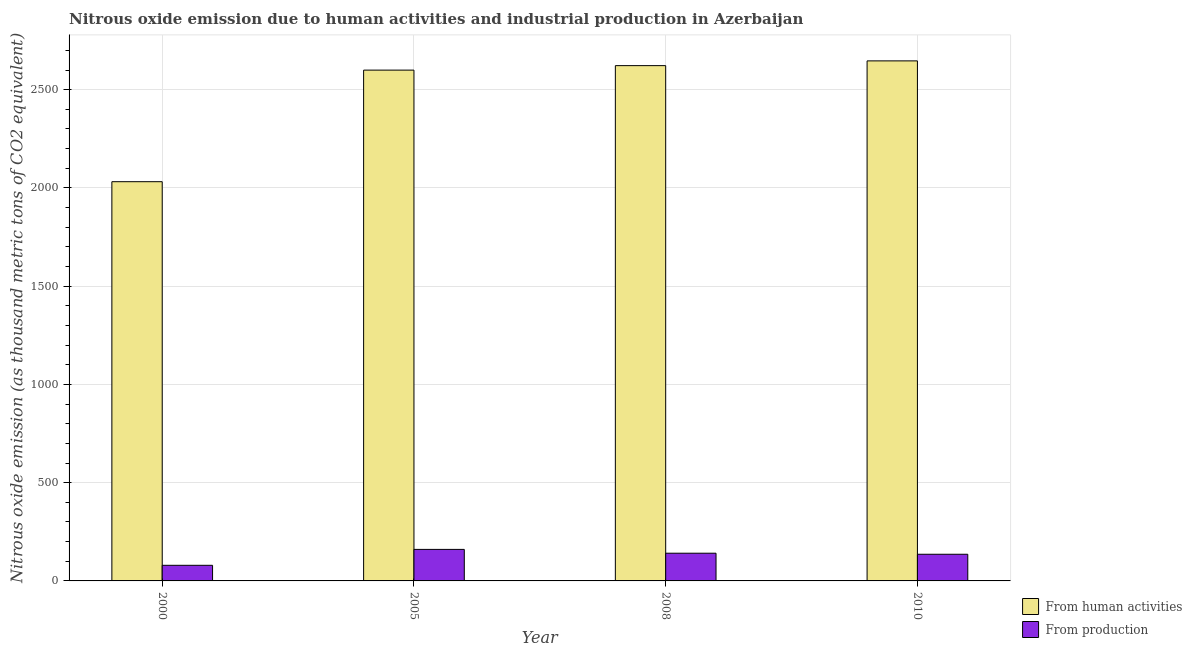How many different coloured bars are there?
Your answer should be very brief. 2. How many groups of bars are there?
Your response must be concise. 4. Are the number of bars per tick equal to the number of legend labels?
Your answer should be very brief. Yes. Are the number of bars on each tick of the X-axis equal?
Keep it short and to the point. Yes. How many bars are there on the 4th tick from the left?
Keep it short and to the point. 2. How many bars are there on the 1st tick from the right?
Offer a very short reply. 2. In how many cases, is the number of bars for a given year not equal to the number of legend labels?
Your answer should be compact. 0. What is the amount of emissions generated from industries in 2000?
Keep it short and to the point. 79.5. Across all years, what is the maximum amount of emissions generated from industries?
Provide a short and direct response. 160.4. Across all years, what is the minimum amount of emissions generated from industries?
Your response must be concise. 79.5. In which year was the amount of emissions from human activities minimum?
Offer a very short reply. 2000. What is the total amount of emissions generated from industries in the graph?
Your answer should be compact. 516.6. What is the difference between the amount of emissions from human activities in 2008 and that in 2010?
Keep it short and to the point. -24.2. What is the difference between the amount of emissions generated from industries in 2008 and the amount of emissions from human activities in 2010?
Your answer should be very brief. 5.3. What is the average amount of emissions from human activities per year?
Make the answer very short. 2475.08. What is the ratio of the amount of emissions generated from industries in 2000 to that in 2010?
Your response must be concise. 0.59. What is the difference between the highest and the second highest amount of emissions from human activities?
Offer a terse response. 24.2. What is the difference between the highest and the lowest amount of emissions from human activities?
Your response must be concise. 614.9. Is the sum of the amount of emissions from human activities in 2000 and 2010 greater than the maximum amount of emissions generated from industries across all years?
Make the answer very short. Yes. What does the 1st bar from the left in 2005 represents?
Your response must be concise. From human activities. What does the 2nd bar from the right in 2010 represents?
Provide a short and direct response. From human activities. Are the values on the major ticks of Y-axis written in scientific E-notation?
Offer a very short reply. No. Does the graph contain grids?
Give a very brief answer. Yes. What is the title of the graph?
Your response must be concise. Nitrous oxide emission due to human activities and industrial production in Azerbaijan. What is the label or title of the X-axis?
Keep it short and to the point. Year. What is the label or title of the Y-axis?
Provide a succinct answer. Nitrous oxide emission (as thousand metric tons of CO2 equivalent). What is the Nitrous oxide emission (as thousand metric tons of CO2 equivalent) in From human activities in 2000?
Your answer should be very brief. 2031.7. What is the Nitrous oxide emission (as thousand metric tons of CO2 equivalent) of From production in 2000?
Your answer should be compact. 79.5. What is the Nitrous oxide emission (as thousand metric tons of CO2 equivalent) in From human activities in 2005?
Your answer should be compact. 2599.6. What is the Nitrous oxide emission (as thousand metric tons of CO2 equivalent) of From production in 2005?
Your response must be concise. 160.4. What is the Nitrous oxide emission (as thousand metric tons of CO2 equivalent) in From human activities in 2008?
Provide a short and direct response. 2622.4. What is the Nitrous oxide emission (as thousand metric tons of CO2 equivalent) of From production in 2008?
Make the answer very short. 141. What is the Nitrous oxide emission (as thousand metric tons of CO2 equivalent) of From human activities in 2010?
Ensure brevity in your answer.  2646.6. What is the Nitrous oxide emission (as thousand metric tons of CO2 equivalent) of From production in 2010?
Give a very brief answer. 135.7. Across all years, what is the maximum Nitrous oxide emission (as thousand metric tons of CO2 equivalent) in From human activities?
Make the answer very short. 2646.6. Across all years, what is the maximum Nitrous oxide emission (as thousand metric tons of CO2 equivalent) of From production?
Offer a very short reply. 160.4. Across all years, what is the minimum Nitrous oxide emission (as thousand metric tons of CO2 equivalent) in From human activities?
Make the answer very short. 2031.7. Across all years, what is the minimum Nitrous oxide emission (as thousand metric tons of CO2 equivalent) of From production?
Your response must be concise. 79.5. What is the total Nitrous oxide emission (as thousand metric tons of CO2 equivalent) of From human activities in the graph?
Offer a very short reply. 9900.3. What is the total Nitrous oxide emission (as thousand metric tons of CO2 equivalent) in From production in the graph?
Give a very brief answer. 516.6. What is the difference between the Nitrous oxide emission (as thousand metric tons of CO2 equivalent) of From human activities in 2000 and that in 2005?
Provide a succinct answer. -567.9. What is the difference between the Nitrous oxide emission (as thousand metric tons of CO2 equivalent) in From production in 2000 and that in 2005?
Keep it short and to the point. -80.9. What is the difference between the Nitrous oxide emission (as thousand metric tons of CO2 equivalent) of From human activities in 2000 and that in 2008?
Ensure brevity in your answer.  -590.7. What is the difference between the Nitrous oxide emission (as thousand metric tons of CO2 equivalent) of From production in 2000 and that in 2008?
Your answer should be compact. -61.5. What is the difference between the Nitrous oxide emission (as thousand metric tons of CO2 equivalent) of From human activities in 2000 and that in 2010?
Ensure brevity in your answer.  -614.9. What is the difference between the Nitrous oxide emission (as thousand metric tons of CO2 equivalent) of From production in 2000 and that in 2010?
Provide a short and direct response. -56.2. What is the difference between the Nitrous oxide emission (as thousand metric tons of CO2 equivalent) in From human activities in 2005 and that in 2008?
Make the answer very short. -22.8. What is the difference between the Nitrous oxide emission (as thousand metric tons of CO2 equivalent) of From production in 2005 and that in 2008?
Give a very brief answer. 19.4. What is the difference between the Nitrous oxide emission (as thousand metric tons of CO2 equivalent) of From human activities in 2005 and that in 2010?
Your response must be concise. -47. What is the difference between the Nitrous oxide emission (as thousand metric tons of CO2 equivalent) in From production in 2005 and that in 2010?
Offer a terse response. 24.7. What is the difference between the Nitrous oxide emission (as thousand metric tons of CO2 equivalent) in From human activities in 2008 and that in 2010?
Provide a short and direct response. -24.2. What is the difference between the Nitrous oxide emission (as thousand metric tons of CO2 equivalent) in From human activities in 2000 and the Nitrous oxide emission (as thousand metric tons of CO2 equivalent) in From production in 2005?
Keep it short and to the point. 1871.3. What is the difference between the Nitrous oxide emission (as thousand metric tons of CO2 equivalent) in From human activities in 2000 and the Nitrous oxide emission (as thousand metric tons of CO2 equivalent) in From production in 2008?
Provide a short and direct response. 1890.7. What is the difference between the Nitrous oxide emission (as thousand metric tons of CO2 equivalent) of From human activities in 2000 and the Nitrous oxide emission (as thousand metric tons of CO2 equivalent) of From production in 2010?
Give a very brief answer. 1896. What is the difference between the Nitrous oxide emission (as thousand metric tons of CO2 equivalent) of From human activities in 2005 and the Nitrous oxide emission (as thousand metric tons of CO2 equivalent) of From production in 2008?
Keep it short and to the point. 2458.6. What is the difference between the Nitrous oxide emission (as thousand metric tons of CO2 equivalent) of From human activities in 2005 and the Nitrous oxide emission (as thousand metric tons of CO2 equivalent) of From production in 2010?
Offer a terse response. 2463.9. What is the difference between the Nitrous oxide emission (as thousand metric tons of CO2 equivalent) in From human activities in 2008 and the Nitrous oxide emission (as thousand metric tons of CO2 equivalent) in From production in 2010?
Your answer should be compact. 2486.7. What is the average Nitrous oxide emission (as thousand metric tons of CO2 equivalent) of From human activities per year?
Make the answer very short. 2475.07. What is the average Nitrous oxide emission (as thousand metric tons of CO2 equivalent) in From production per year?
Offer a terse response. 129.15. In the year 2000, what is the difference between the Nitrous oxide emission (as thousand metric tons of CO2 equivalent) of From human activities and Nitrous oxide emission (as thousand metric tons of CO2 equivalent) of From production?
Provide a short and direct response. 1952.2. In the year 2005, what is the difference between the Nitrous oxide emission (as thousand metric tons of CO2 equivalent) in From human activities and Nitrous oxide emission (as thousand metric tons of CO2 equivalent) in From production?
Make the answer very short. 2439.2. In the year 2008, what is the difference between the Nitrous oxide emission (as thousand metric tons of CO2 equivalent) in From human activities and Nitrous oxide emission (as thousand metric tons of CO2 equivalent) in From production?
Provide a succinct answer. 2481.4. In the year 2010, what is the difference between the Nitrous oxide emission (as thousand metric tons of CO2 equivalent) of From human activities and Nitrous oxide emission (as thousand metric tons of CO2 equivalent) of From production?
Ensure brevity in your answer.  2510.9. What is the ratio of the Nitrous oxide emission (as thousand metric tons of CO2 equivalent) in From human activities in 2000 to that in 2005?
Give a very brief answer. 0.78. What is the ratio of the Nitrous oxide emission (as thousand metric tons of CO2 equivalent) of From production in 2000 to that in 2005?
Your answer should be very brief. 0.5. What is the ratio of the Nitrous oxide emission (as thousand metric tons of CO2 equivalent) of From human activities in 2000 to that in 2008?
Keep it short and to the point. 0.77. What is the ratio of the Nitrous oxide emission (as thousand metric tons of CO2 equivalent) in From production in 2000 to that in 2008?
Your response must be concise. 0.56. What is the ratio of the Nitrous oxide emission (as thousand metric tons of CO2 equivalent) of From human activities in 2000 to that in 2010?
Offer a very short reply. 0.77. What is the ratio of the Nitrous oxide emission (as thousand metric tons of CO2 equivalent) in From production in 2000 to that in 2010?
Your answer should be very brief. 0.59. What is the ratio of the Nitrous oxide emission (as thousand metric tons of CO2 equivalent) of From human activities in 2005 to that in 2008?
Offer a very short reply. 0.99. What is the ratio of the Nitrous oxide emission (as thousand metric tons of CO2 equivalent) in From production in 2005 to that in 2008?
Offer a terse response. 1.14. What is the ratio of the Nitrous oxide emission (as thousand metric tons of CO2 equivalent) of From human activities in 2005 to that in 2010?
Your answer should be compact. 0.98. What is the ratio of the Nitrous oxide emission (as thousand metric tons of CO2 equivalent) of From production in 2005 to that in 2010?
Your answer should be compact. 1.18. What is the ratio of the Nitrous oxide emission (as thousand metric tons of CO2 equivalent) of From human activities in 2008 to that in 2010?
Your answer should be very brief. 0.99. What is the ratio of the Nitrous oxide emission (as thousand metric tons of CO2 equivalent) in From production in 2008 to that in 2010?
Your answer should be very brief. 1.04. What is the difference between the highest and the second highest Nitrous oxide emission (as thousand metric tons of CO2 equivalent) in From human activities?
Provide a short and direct response. 24.2. What is the difference between the highest and the lowest Nitrous oxide emission (as thousand metric tons of CO2 equivalent) of From human activities?
Ensure brevity in your answer.  614.9. What is the difference between the highest and the lowest Nitrous oxide emission (as thousand metric tons of CO2 equivalent) of From production?
Provide a short and direct response. 80.9. 